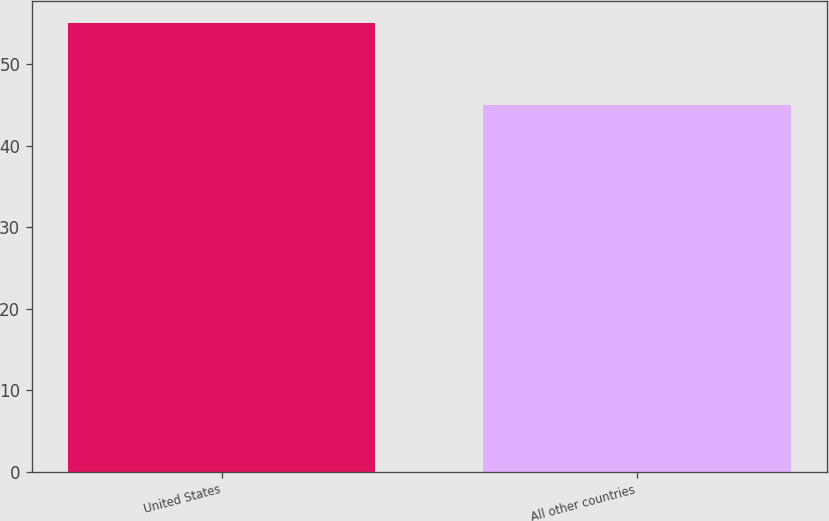Convert chart. <chart><loc_0><loc_0><loc_500><loc_500><bar_chart><fcel>United States<fcel>All other countries<nl><fcel>55<fcel>45<nl></chart> 